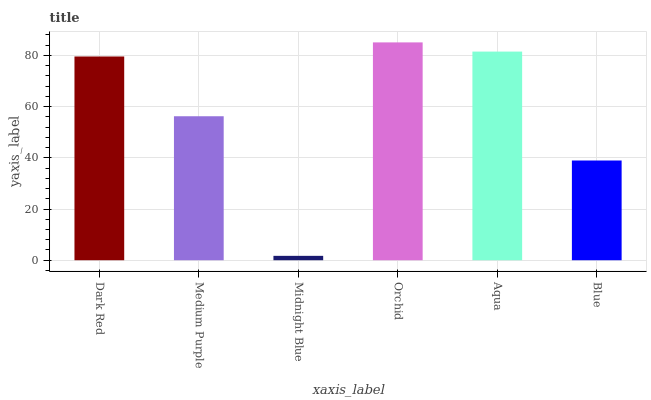Is Midnight Blue the minimum?
Answer yes or no. Yes. Is Orchid the maximum?
Answer yes or no. Yes. Is Medium Purple the minimum?
Answer yes or no. No. Is Medium Purple the maximum?
Answer yes or no. No. Is Dark Red greater than Medium Purple?
Answer yes or no. Yes. Is Medium Purple less than Dark Red?
Answer yes or no. Yes. Is Medium Purple greater than Dark Red?
Answer yes or no. No. Is Dark Red less than Medium Purple?
Answer yes or no. No. Is Dark Red the high median?
Answer yes or no. Yes. Is Medium Purple the low median?
Answer yes or no. Yes. Is Aqua the high median?
Answer yes or no. No. Is Orchid the low median?
Answer yes or no. No. 